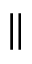<formula> <loc_0><loc_0><loc_500><loc_500>\|</formula> 